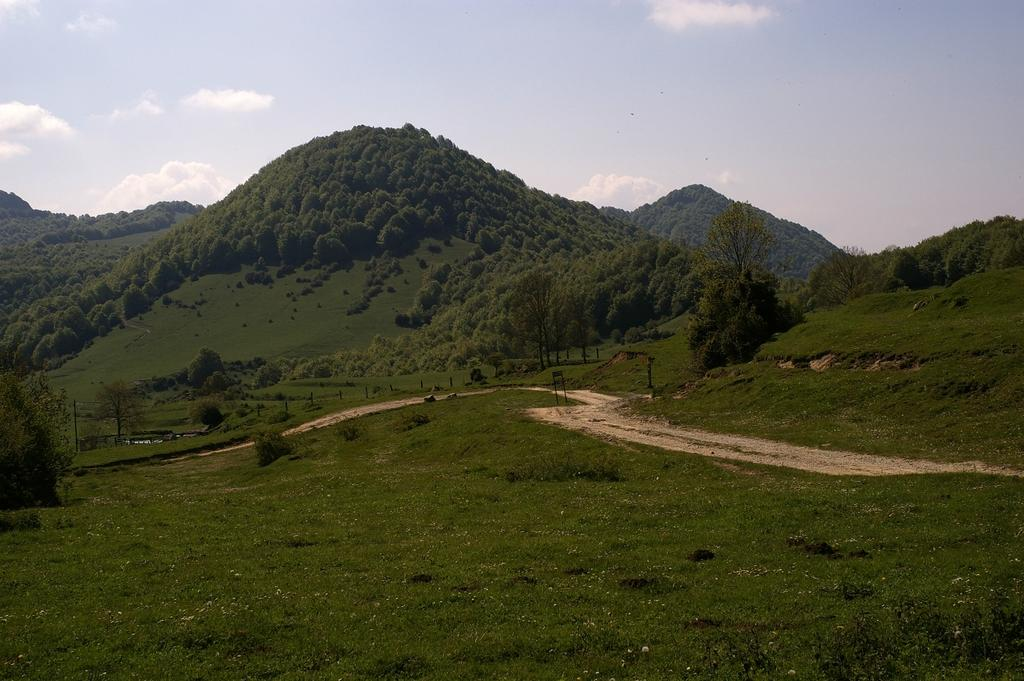What type of vegetation can be seen in the image? There are trees, plants, and grass visible in the image. What is the condition of the sky in the image? The sky is cloudy in the image. What type of natural landform can be seen in the distance? There are mountains visible in the image. What type of popcorn can be seen growing on the trees in the image? There is no popcorn present in the image; the trees are not popcorn trees. How many feet are visible in the image? There are no feet visible in the image; it is a landscape scene with no people or animals present. 